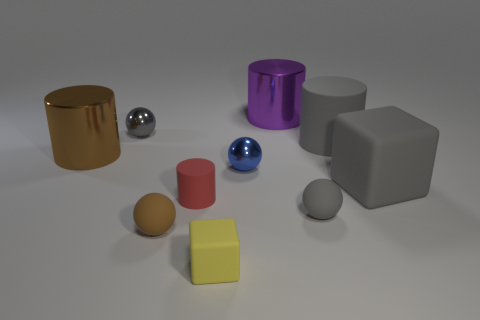Subtract all small rubber cylinders. How many cylinders are left? 3 Subtract 2 spheres. How many spheres are left? 2 Subtract all yellow blocks. How many blocks are left? 1 Subtract 0 blue blocks. How many objects are left? 10 Subtract all cylinders. How many objects are left? 6 Subtract all gray balls. Subtract all blue cubes. How many balls are left? 2 Subtract all blue cylinders. How many blue spheres are left? 1 Subtract all gray objects. Subtract all tiny yellow matte cubes. How many objects are left? 5 Add 5 large shiny cylinders. How many large shiny cylinders are left? 7 Add 9 purple cylinders. How many purple cylinders exist? 10 